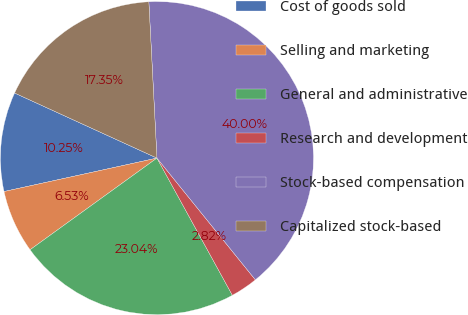Convert chart to OTSL. <chart><loc_0><loc_0><loc_500><loc_500><pie_chart><fcel>Cost of goods sold<fcel>Selling and marketing<fcel>General and administrative<fcel>Research and development<fcel>Stock-based compensation<fcel>Capitalized stock-based<nl><fcel>10.25%<fcel>6.53%<fcel>23.04%<fcel>2.82%<fcel>40.0%<fcel>17.35%<nl></chart> 